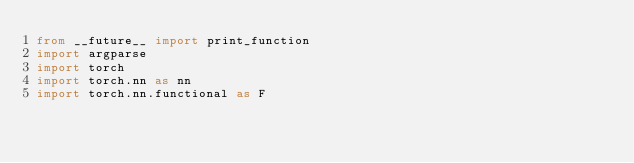<code> <loc_0><loc_0><loc_500><loc_500><_Python_>from __future__ import print_function
import argparse
import torch
import torch.nn as nn
import torch.nn.functional as F</code> 